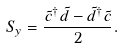<formula> <loc_0><loc_0><loc_500><loc_500>S _ { y } = \frac { \tilde { c } ^ { \dagger } \tilde { d } - \tilde { d } ^ { \dagger } \tilde { c } } { 2 } .</formula> 